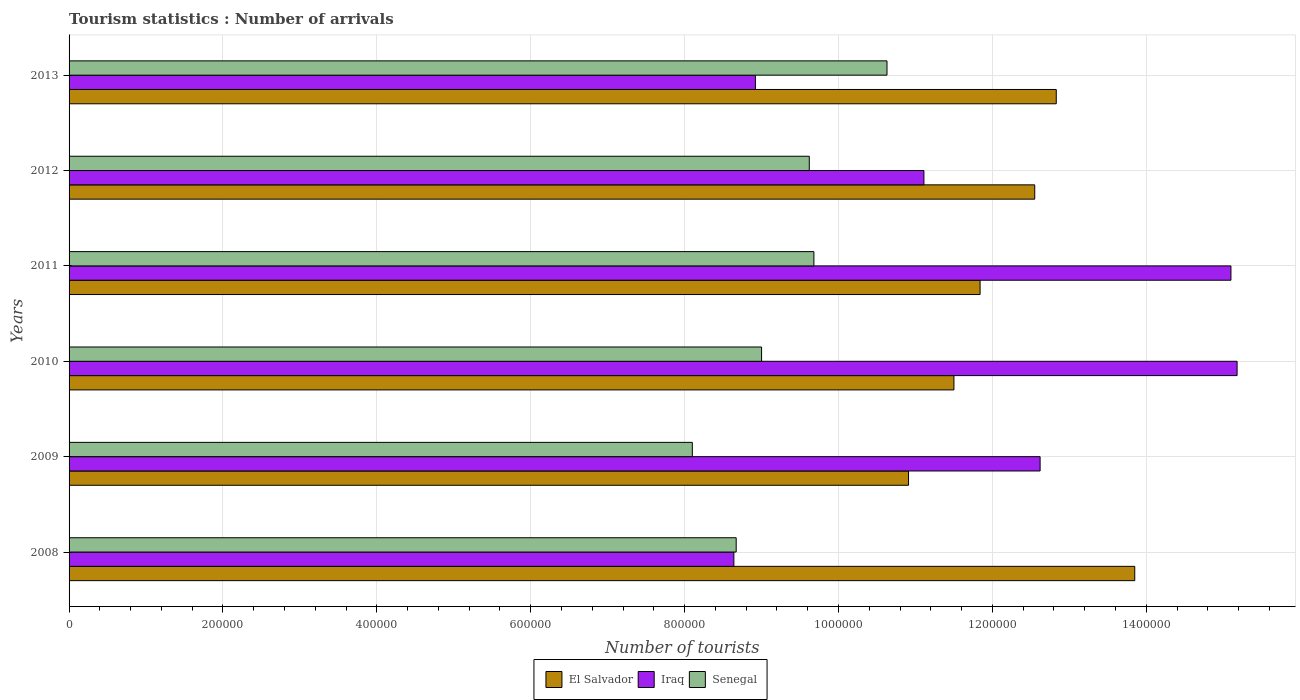How many different coloured bars are there?
Offer a very short reply. 3. How many groups of bars are there?
Your answer should be very brief. 6. Are the number of bars on each tick of the Y-axis equal?
Provide a short and direct response. Yes. What is the label of the 5th group of bars from the top?
Ensure brevity in your answer.  2009. What is the number of tourist arrivals in Iraq in 2012?
Your response must be concise. 1.11e+06. Across all years, what is the maximum number of tourist arrivals in Senegal?
Your response must be concise. 1.06e+06. Across all years, what is the minimum number of tourist arrivals in Iraq?
Ensure brevity in your answer.  8.64e+05. In which year was the number of tourist arrivals in Senegal maximum?
Your answer should be compact. 2013. In which year was the number of tourist arrivals in Iraq minimum?
Your answer should be very brief. 2008. What is the total number of tourist arrivals in Iraq in the graph?
Provide a succinct answer. 7.16e+06. What is the difference between the number of tourist arrivals in El Salvador in 2009 and that in 2011?
Give a very brief answer. -9.30e+04. What is the difference between the number of tourist arrivals in Senegal in 2009 and the number of tourist arrivals in Iraq in 2013?
Your answer should be very brief. -8.20e+04. What is the average number of tourist arrivals in El Salvador per year?
Make the answer very short. 1.22e+06. In the year 2013, what is the difference between the number of tourist arrivals in Senegal and number of tourist arrivals in Iraq?
Keep it short and to the point. 1.71e+05. In how many years, is the number of tourist arrivals in Iraq greater than 440000 ?
Your answer should be very brief. 6. What is the ratio of the number of tourist arrivals in Iraq in 2008 to that in 2010?
Keep it short and to the point. 0.57. Is the number of tourist arrivals in El Salvador in 2011 less than that in 2013?
Provide a short and direct response. Yes. What is the difference between the highest and the second highest number of tourist arrivals in Senegal?
Ensure brevity in your answer.  9.50e+04. What is the difference between the highest and the lowest number of tourist arrivals in Iraq?
Make the answer very short. 6.54e+05. What does the 2nd bar from the top in 2010 represents?
Offer a terse response. Iraq. What does the 1st bar from the bottom in 2011 represents?
Provide a short and direct response. El Salvador. How many years are there in the graph?
Give a very brief answer. 6. Does the graph contain grids?
Your answer should be very brief. Yes. Where does the legend appear in the graph?
Your response must be concise. Bottom center. What is the title of the graph?
Give a very brief answer. Tourism statistics : Number of arrivals. What is the label or title of the X-axis?
Your answer should be very brief. Number of tourists. What is the Number of tourists in El Salvador in 2008?
Your answer should be very brief. 1.38e+06. What is the Number of tourists of Iraq in 2008?
Your answer should be very brief. 8.64e+05. What is the Number of tourists in Senegal in 2008?
Give a very brief answer. 8.67e+05. What is the Number of tourists in El Salvador in 2009?
Offer a terse response. 1.09e+06. What is the Number of tourists of Iraq in 2009?
Ensure brevity in your answer.  1.26e+06. What is the Number of tourists of Senegal in 2009?
Give a very brief answer. 8.10e+05. What is the Number of tourists of El Salvador in 2010?
Offer a terse response. 1.15e+06. What is the Number of tourists of Iraq in 2010?
Your answer should be very brief. 1.52e+06. What is the Number of tourists of Senegal in 2010?
Offer a terse response. 9.00e+05. What is the Number of tourists of El Salvador in 2011?
Your response must be concise. 1.18e+06. What is the Number of tourists of Iraq in 2011?
Your response must be concise. 1.51e+06. What is the Number of tourists of Senegal in 2011?
Ensure brevity in your answer.  9.68e+05. What is the Number of tourists of El Salvador in 2012?
Offer a very short reply. 1.26e+06. What is the Number of tourists of Iraq in 2012?
Offer a terse response. 1.11e+06. What is the Number of tourists of Senegal in 2012?
Give a very brief answer. 9.62e+05. What is the Number of tourists of El Salvador in 2013?
Your answer should be compact. 1.28e+06. What is the Number of tourists of Iraq in 2013?
Your answer should be very brief. 8.92e+05. What is the Number of tourists in Senegal in 2013?
Offer a terse response. 1.06e+06. Across all years, what is the maximum Number of tourists of El Salvador?
Your answer should be very brief. 1.38e+06. Across all years, what is the maximum Number of tourists in Iraq?
Ensure brevity in your answer.  1.52e+06. Across all years, what is the maximum Number of tourists of Senegal?
Offer a very short reply. 1.06e+06. Across all years, what is the minimum Number of tourists of El Salvador?
Your answer should be compact. 1.09e+06. Across all years, what is the minimum Number of tourists in Iraq?
Give a very brief answer. 8.64e+05. Across all years, what is the minimum Number of tourists of Senegal?
Your response must be concise. 8.10e+05. What is the total Number of tourists in El Salvador in the graph?
Keep it short and to the point. 7.35e+06. What is the total Number of tourists of Iraq in the graph?
Your answer should be very brief. 7.16e+06. What is the total Number of tourists of Senegal in the graph?
Give a very brief answer. 5.57e+06. What is the difference between the Number of tourists in El Salvador in 2008 and that in 2009?
Provide a succinct answer. 2.94e+05. What is the difference between the Number of tourists in Iraq in 2008 and that in 2009?
Offer a very short reply. -3.98e+05. What is the difference between the Number of tourists of Senegal in 2008 and that in 2009?
Your response must be concise. 5.70e+04. What is the difference between the Number of tourists of El Salvador in 2008 and that in 2010?
Provide a succinct answer. 2.35e+05. What is the difference between the Number of tourists of Iraq in 2008 and that in 2010?
Offer a very short reply. -6.54e+05. What is the difference between the Number of tourists in Senegal in 2008 and that in 2010?
Offer a terse response. -3.30e+04. What is the difference between the Number of tourists of El Salvador in 2008 and that in 2011?
Your answer should be compact. 2.01e+05. What is the difference between the Number of tourists of Iraq in 2008 and that in 2011?
Your answer should be compact. -6.46e+05. What is the difference between the Number of tourists of Senegal in 2008 and that in 2011?
Give a very brief answer. -1.01e+05. What is the difference between the Number of tourists in Iraq in 2008 and that in 2012?
Provide a short and direct response. -2.47e+05. What is the difference between the Number of tourists in Senegal in 2008 and that in 2012?
Provide a succinct answer. -9.50e+04. What is the difference between the Number of tourists in El Salvador in 2008 and that in 2013?
Make the answer very short. 1.02e+05. What is the difference between the Number of tourists of Iraq in 2008 and that in 2013?
Your response must be concise. -2.80e+04. What is the difference between the Number of tourists of Senegal in 2008 and that in 2013?
Offer a very short reply. -1.96e+05. What is the difference between the Number of tourists of El Salvador in 2009 and that in 2010?
Ensure brevity in your answer.  -5.90e+04. What is the difference between the Number of tourists of Iraq in 2009 and that in 2010?
Offer a terse response. -2.56e+05. What is the difference between the Number of tourists of El Salvador in 2009 and that in 2011?
Offer a terse response. -9.30e+04. What is the difference between the Number of tourists in Iraq in 2009 and that in 2011?
Provide a succinct answer. -2.48e+05. What is the difference between the Number of tourists in Senegal in 2009 and that in 2011?
Provide a short and direct response. -1.58e+05. What is the difference between the Number of tourists of El Salvador in 2009 and that in 2012?
Your answer should be compact. -1.64e+05. What is the difference between the Number of tourists of Iraq in 2009 and that in 2012?
Your answer should be very brief. 1.51e+05. What is the difference between the Number of tourists of Senegal in 2009 and that in 2012?
Give a very brief answer. -1.52e+05. What is the difference between the Number of tourists in El Salvador in 2009 and that in 2013?
Keep it short and to the point. -1.92e+05. What is the difference between the Number of tourists in Iraq in 2009 and that in 2013?
Your response must be concise. 3.70e+05. What is the difference between the Number of tourists of Senegal in 2009 and that in 2013?
Keep it short and to the point. -2.53e+05. What is the difference between the Number of tourists in El Salvador in 2010 and that in 2011?
Make the answer very short. -3.40e+04. What is the difference between the Number of tourists of Iraq in 2010 and that in 2011?
Offer a terse response. 8000. What is the difference between the Number of tourists in Senegal in 2010 and that in 2011?
Provide a short and direct response. -6.80e+04. What is the difference between the Number of tourists of El Salvador in 2010 and that in 2012?
Keep it short and to the point. -1.05e+05. What is the difference between the Number of tourists in Iraq in 2010 and that in 2012?
Your response must be concise. 4.07e+05. What is the difference between the Number of tourists of Senegal in 2010 and that in 2012?
Provide a succinct answer. -6.20e+04. What is the difference between the Number of tourists of El Salvador in 2010 and that in 2013?
Provide a succinct answer. -1.33e+05. What is the difference between the Number of tourists of Iraq in 2010 and that in 2013?
Offer a terse response. 6.26e+05. What is the difference between the Number of tourists in Senegal in 2010 and that in 2013?
Give a very brief answer. -1.63e+05. What is the difference between the Number of tourists of El Salvador in 2011 and that in 2012?
Provide a short and direct response. -7.10e+04. What is the difference between the Number of tourists in Iraq in 2011 and that in 2012?
Your answer should be compact. 3.99e+05. What is the difference between the Number of tourists in Senegal in 2011 and that in 2012?
Offer a very short reply. 6000. What is the difference between the Number of tourists in El Salvador in 2011 and that in 2013?
Keep it short and to the point. -9.90e+04. What is the difference between the Number of tourists of Iraq in 2011 and that in 2013?
Provide a short and direct response. 6.18e+05. What is the difference between the Number of tourists of Senegal in 2011 and that in 2013?
Your response must be concise. -9.50e+04. What is the difference between the Number of tourists in El Salvador in 2012 and that in 2013?
Give a very brief answer. -2.80e+04. What is the difference between the Number of tourists of Iraq in 2012 and that in 2013?
Make the answer very short. 2.19e+05. What is the difference between the Number of tourists in Senegal in 2012 and that in 2013?
Provide a short and direct response. -1.01e+05. What is the difference between the Number of tourists of El Salvador in 2008 and the Number of tourists of Iraq in 2009?
Keep it short and to the point. 1.23e+05. What is the difference between the Number of tourists in El Salvador in 2008 and the Number of tourists in Senegal in 2009?
Ensure brevity in your answer.  5.75e+05. What is the difference between the Number of tourists of Iraq in 2008 and the Number of tourists of Senegal in 2009?
Your response must be concise. 5.40e+04. What is the difference between the Number of tourists in El Salvador in 2008 and the Number of tourists in Iraq in 2010?
Offer a very short reply. -1.33e+05. What is the difference between the Number of tourists in El Salvador in 2008 and the Number of tourists in Senegal in 2010?
Ensure brevity in your answer.  4.85e+05. What is the difference between the Number of tourists in Iraq in 2008 and the Number of tourists in Senegal in 2010?
Make the answer very short. -3.60e+04. What is the difference between the Number of tourists of El Salvador in 2008 and the Number of tourists of Iraq in 2011?
Provide a short and direct response. -1.25e+05. What is the difference between the Number of tourists in El Salvador in 2008 and the Number of tourists in Senegal in 2011?
Your answer should be very brief. 4.17e+05. What is the difference between the Number of tourists of Iraq in 2008 and the Number of tourists of Senegal in 2011?
Your answer should be compact. -1.04e+05. What is the difference between the Number of tourists of El Salvador in 2008 and the Number of tourists of Iraq in 2012?
Make the answer very short. 2.74e+05. What is the difference between the Number of tourists of El Salvador in 2008 and the Number of tourists of Senegal in 2012?
Your response must be concise. 4.23e+05. What is the difference between the Number of tourists of Iraq in 2008 and the Number of tourists of Senegal in 2012?
Provide a short and direct response. -9.80e+04. What is the difference between the Number of tourists of El Salvador in 2008 and the Number of tourists of Iraq in 2013?
Provide a short and direct response. 4.93e+05. What is the difference between the Number of tourists in El Salvador in 2008 and the Number of tourists in Senegal in 2013?
Your answer should be very brief. 3.22e+05. What is the difference between the Number of tourists in Iraq in 2008 and the Number of tourists in Senegal in 2013?
Your answer should be very brief. -1.99e+05. What is the difference between the Number of tourists in El Salvador in 2009 and the Number of tourists in Iraq in 2010?
Provide a succinct answer. -4.27e+05. What is the difference between the Number of tourists in El Salvador in 2009 and the Number of tourists in Senegal in 2010?
Make the answer very short. 1.91e+05. What is the difference between the Number of tourists in Iraq in 2009 and the Number of tourists in Senegal in 2010?
Offer a very short reply. 3.62e+05. What is the difference between the Number of tourists in El Salvador in 2009 and the Number of tourists in Iraq in 2011?
Give a very brief answer. -4.19e+05. What is the difference between the Number of tourists in El Salvador in 2009 and the Number of tourists in Senegal in 2011?
Offer a very short reply. 1.23e+05. What is the difference between the Number of tourists in Iraq in 2009 and the Number of tourists in Senegal in 2011?
Your answer should be compact. 2.94e+05. What is the difference between the Number of tourists in El Salvador in 2009 and the Number of tourists in Senegal in 2012?
Offer a very short reply. 1.29e+05. What is the difference between the Number of tourists in El Salvador in 2009 and the Number of tourists in Iraq in 2013?
Keep it short and to the point. 1.99e+05. What is the difference between the Number of tourists in El Salvador in 2009 and the Number of tourists in Senegal in 2013?
Ensure brevity in your answer.  2.80e+04. What is the difference between the Number of tourists of Iraq in 2009 and the Number of tourists of Senegal in 2013?
Make the answer very short. 1.99e+05. What is the difference between the Number of tourists in El Salvador in 2010 and the Number of tourists in Iraq in 2011?
Offer a very short reply. -3.60e+05. What is the difference between the Number of tourists of El Salvador in 2010 and the Number of tourists of Senegal in 2011?
Your answer should be compact. 1.82e+05. What is the difference between the Number of tourists in El Salvador in 2010 and the Number of tourists in Iraq in 2012?
Your answer should be compact. 3.90e+04. What is the difference between the Number of tourists in El Salvador in 2010 and the Number of tourists in Senegal in 2012?
Give a very brief answer. 1.88e+05. What is the difference between the Number of tourists of Iraq in 2010 and the Number of tourists of Senegal in 2012?
Give a very brief answer. 5.56e+05. What is the difference between the Number of tourists of El Salvador in 2010 and the Number of tourists of Iraq in 2013?
Offer a very short reply. 2.58e+05. What is the difference between the Number of tourists of El Salvador in 2010 and the Number of tourists of Senegal in 2013?
Your answer should be very brief. 8.70e+04. What is the difference between the Number of tourists in Iraq in 2010 and the Number of tourists in Senegal in 2013?
Keep it short and to the point. 4.55e+05. What is the difference between the Number of tourists of El Salvador in 2011 and the Number of tourists of Iraq in 2012?
Offer a terse response. 7.30e+04. What is the difference between the Number of tourists in El Salvador in 2011 and the Number of tourists in Senegal in 2012?
Offer a very short reply. 2.22e+05. What is the difference between the Number of tourists of Iraq in 2011 and the Number of tourists of Senegal in 2012?
Offer a terse response. 5.48e+05. What is the difference between the Number of tourists in El Salvador in 2011 and the Number of tourists in Iraq in 2013?
Keep it short and to the point. 2.92e+05. What is the difference between the Number of tourists of El Salvador in 2011 and the Number of tourists of Senegal in 2013?
Provide a succinct answer. 1.21e+05. What is the difference between the Number of tourists in Iraq in 2011 and the Number of tourists in Senegal in 2013?
Make the answer very short. 4.47e+05. What is the difference between the Number of tourists in El Salvador in 2012 and the Number of tourists in Iraq in 2013?
Offer a very short reply. 3.63e+05. What is the difference between the Number of tourists in El Salvador in 2012 and the Number of tourists in Senegal in 2013?
Your answer should be compact. 1.92e+05. What is the difference between the Number of tourists in Iraq in 2012 and the Number of tourists in Senegal in 2013?
Provide a succinct answer. 4.80e+04. What is the average Number of tourists of El Salvador per year?
Your answer should be very brief. 1.22e+06. What is the average Number of tourists in Iraq per year?
Ensure brevity in your answer.  1.19e+06. What is the average Number of tourists in Senegal per year?
Make the answer very short. 9.28e+05. In the year 2008, what is the difference between the Number of tourists of El Salvador and Number of tourists of Iraq?
Your response must be concise. 5.21e+05. In the year 2008, what is the difference between the Number of tourists of El Salvador and Number of tourists of Senegal?
Provide a short and direct response. 5.18e+05. In the year 2008, what is the difference between the Number of tourists of Iraq and Number of tourists of Senegal?
Keep it short and to the point. -3000. In the year 2009, what is the difference between the Number of tourists in El Salvador and Number of tourists in Iraq?
Provide a short and direct response. -1.71e+05. In the year 2009, what is the difference between the Number of tourists of El Salvador and Number of tourists of Senegal?
Provide a succinct answer. 2.81e+05. In the year 2009, what is the difference between the Number of tourists in Iraq and Number of tourists in Senegal?
Keep it short and to the point. 4.52e+05. In the year 2010, what is the difference between the Number of tourists of El Salvador and Number of tourists of Iraq?
Provide a short and direct response. -3.68e+05. In the year 2010, what is the difference between the Number of tourists in Iraq and Number of tourists in Senegal?
Offer a terse response. 6.18e+05. In the year 2011, what is the difference between the Number of tourists of El Salvador and Number of tourists of Iraq?
Your answer should be compact. -3.26e+05. In the year 2011, what is the difference between the Number of tourists in El Salvador and Number of tourists in Senegal?
Keep it short and to the point. 2.16e+05. In the year 2011, what is the difference between the Number of tourists in Iraq and Number of tourists in Senegal?
Provide a short and direct response. 5.42e+05. In the year 2012, what is the difference between the Number of tourists in El Salvador and Number of tourists in Iraq?
Provide a short and direct response. 1.44e+05. In the year 2012, what is the difference between the Number of tourists of El Salvador and Number of tourists of Senegal?
Ensure brevity in your answer.  2.93e+05. In the year 2012, what is the difference between the Number of tourists of Iraq and Number of tourists of Senegal?
Make the answer very short. 1.49e+05. In the year 2013, what is the difference between the Number of tourists in El Salvador and Number of tourists in Iraq?
Your answer should be very brief. 3.91e+05. In the year 2013, what is the difference between the Number of tourists of El Salvador and Number of tourists of Senegal?
Give a very brief answer. 2.20e+05. In the year 2013, what is the difference between the Number of tourists in Iraq and Number of tourists in Senegal?
Keep it short and to the point. -1.71e+05. What is the ratio of the Number of tourists of El Salvador in 2008 to that in 2009?
Keep it short and to the point. 1.27. What is the ratio of the Number of tourists in Iraq in 2008 to that in 2009?
Your answer should be compact. 0.68. What is the ratio of the Number of tourists of Senegal in 2008 to that in 2009?
Your response must be concise. 1.07. What is the ratio of the Number of tourists in El Salvador in 2008 to that in 2010?
Provide a short and direct response. 1.2. What is the ratio of the Number of tourists in Iraq in 2008 to that in 2010?
Provide a short and direct response. 0.57. What is the ratio of the Number of tourists in Senegal in 2008 to that in 2010?
Offer a terse response. 0.96. What is the ratio of the Number of tourists in El Salvador in 2008 to that in 2011?
Make the answer very short. 1.17. What is the ratio of the Number of tourists of Iraq in 2008 to that in 2011?
Give a very brief answer. 0.57. What is the ratio of the Number of tourists of Senegal in 2008 to that in 2011?
Your response must be concise. 0.9. What is the ratio of the Number of tourists in El Salvador in 2008 to that in 2012?
Give a very brief answer. 1.1. What is the ratio of the Number of tourists in Iraq in 2008 to that in 2012?
Keep it short and to the point. 0.78. What is the ratio of the Number of tourists in Senegal in 2008 to that in 2012?
Keep it short and to the point. 0.9. What is the ratio of the Number of tourists of El Salvador in 2008 to that in 2013?
Ensure brevity in your answer.  1.08. What is the ratio of the Number of tourists of Iraq in 2008 to that in 2013?
Give a very brief answer. 0.97. What is the ratio of the Number of tourists of Senegal in 2008 to that in 2013?
Ensure brevity in your answer.  0.82. What is the ratio of the Number of tourists in El Salvador in 2009 to that in 2010?
Provide a succinct answer. 0.95. What is the ratio of the Number of tourists of Iraq in 2009 to that in 2010?
Provide a short and direct response. 0.83. What is the ratio of the Number of tourists of El Salvador in 2009 to that in 2011?
Provide a succinct answer. 0.92. What is the ratio of the Number of tourists of Iraq in 2009 to that in 2011?
Your response must be concise. 0.84. What is the ratio of the Number of tourists in Senegal in 2009 to that in 2011?
Offer a very short reply. 0.84. What is the ratio of the Number of tourists of El Salvador in 2009 to that in 2012?
Offer a very short reply. 0.87. What is the ratio of the Number of tourists of Iraq in 2009 to that in 2012?
Your response must be concise. 1.14. What is the ratio of the Number of tourists in Senegal in 2009 to that in 2012?
Your answer should be very brief. 0.84. What is the ratio of the Number of tourists in El Salvador in 2009 to that in 2013?
Give a very brief answer. 0.85. What is the ratio of the Number of tourists in Iraq in 2009 to that in 2013?
Keep it short and to the point. 1.41. What is the ratio of the Number of tourists of Senegal in 2009 to that in 2013?
Your answer should be compact. 0.76. What is the ratio of the Number of tourists in El Salvador in 2010 to that in 2011?
Make the answer very short. 0.97. What is the ratio of the Number of tourists of Iraq in 2010 to that in 2011?
Your response must be concise. 1.01. What is the ratio of the Number of tourists of Senegal in 2010 to that in 2011?
Offer a terse response. 0.93. What is the ratio of the Number of tourists in El Salvador in 2010 to that in 2012?
Your answer should be compact. 0.92. What is the ratio of the Number of tourists of Iraq in 2010 to that in 2012?
Ensure brevity in your answer.  1.37. What is the ratio of the Number of tourists in Senegal in 2010 to that in 2012?
Provide a short and direct response. 0.94. What is the ratio of the Number of tourists in El Salvador in 2010 to that in 2013?
Your answer should be compact. 0.9. What is the ratio of the Number of tourists in Iraq in 2010 to that in 2013?
Provide a short and direct response. 1.7. What is the ratio of the Number of tourists in Senegal in 2010 to that in 2013?
Your answer should be compact. 0.85. What is the ratio of the Number of tourists of El Salvador in 2011 to that in 2012?
Make the answer very short. 0.94. What is the ratio of the Number of tourists of Iraq in 2011 to that in 2012?
Your answer should be compact. 1.36. What is the ratio of the Number of tourists of Senegal in 2011 to that in 2012?
Give a very brief answer. 1.01. What is the ratio of the Number of tourists of El Salvador in 2011 to that in 2013?
Keep it short and to the point. 0.92. What is the ratio of the Number of tourists in Iraq in 2011 to that in 2013?
Offer a very short reply. 1.69. What is the ratio of the Number of tourists in Senegal in 2011 to that in 2013?
Make the answer very short. 0.91. What is the ratio of the Number of tourists of El Salvador in 2012 to that in 2013?
Keep it short and to the point. 0.98. What is the ratio of the Number of tourists in Iraq in 2012 to that in 2013?
Make the answer very short. 1.25. What is the ratio of the Number of tourists in Senegal in 2012 to that in 2013?
Your answer should be compact. 0.91. What is the difference between the highest and the second highest Number of tourists in El Salvador?
Your response must be concise. 1.02e+05. What is the difference between the highest and the second highest Number of tourists in Iraq?
Your answer should be very brief. 8000. What is the difference between the highest and the second highest Number of tourists of Senegal?
Ensure brevity in your answer.  9.50e+04. What is the difference between the highest and the lowest Number of tourists in El Salvador?
Your answer should be compact. 2.94e+05. What is the difference between the highest and the lowest Number of tourists of Iraq?
Give a very brief answer. 6.54e+05. What is the difference between the highest and the lowest Number of tourists in Senegal?
Provide a short and direct response. 2.53e+05. 